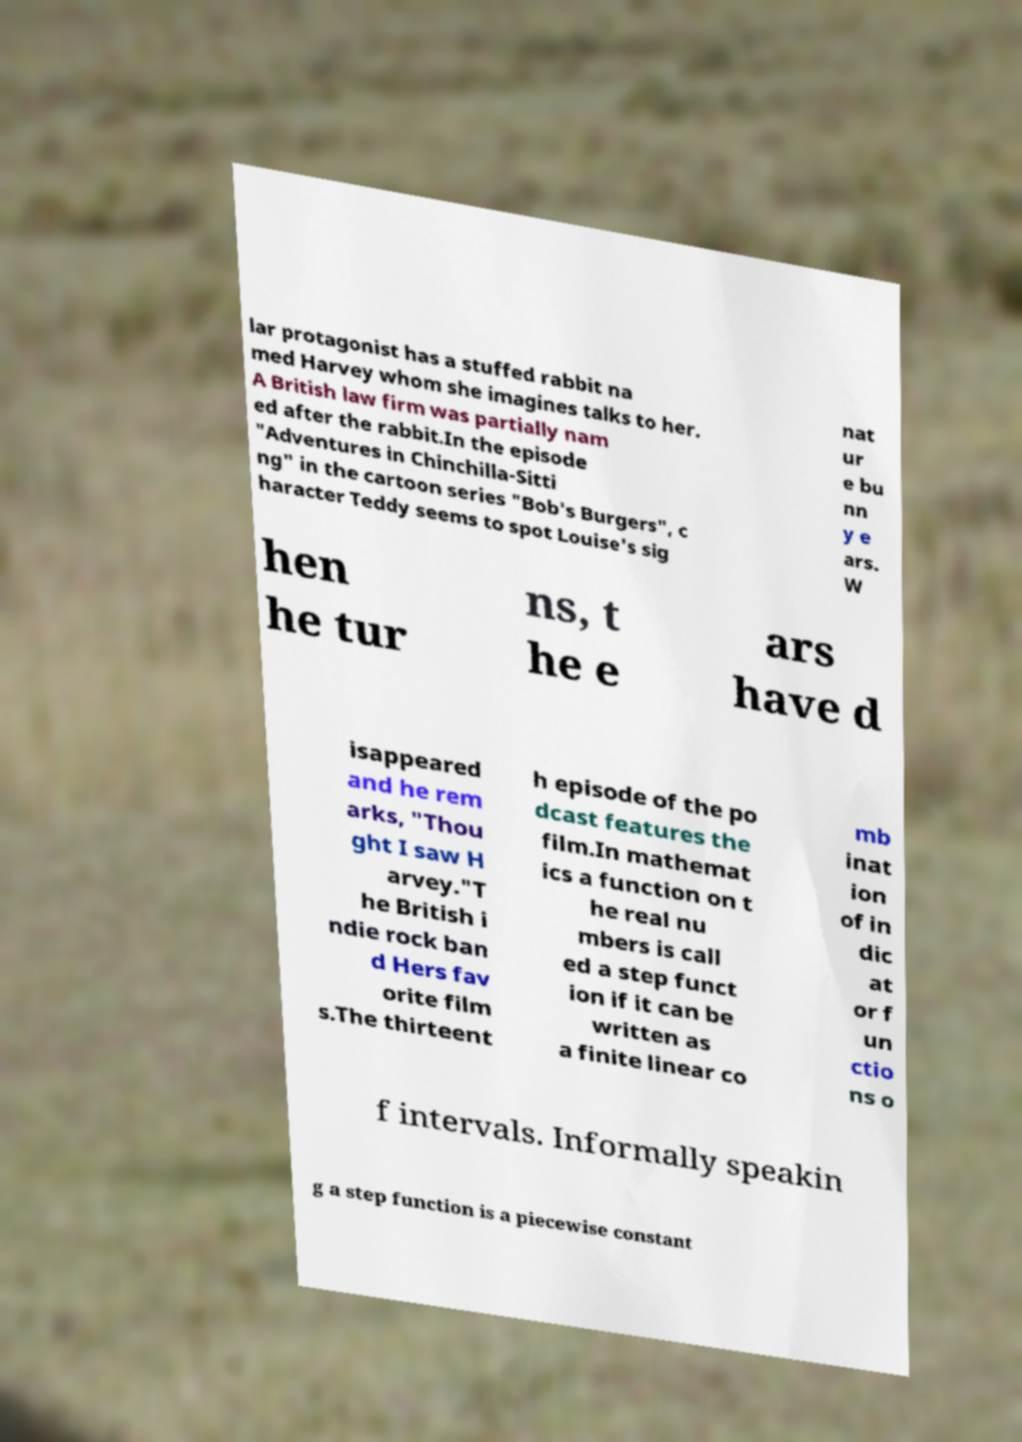Please read and relay the text visible in this image. What does it say? lar protagonist has a stuffed rabbit na med Harvey whom she imagines talks to her. A British law firm was partially nam ed after the rabbit.In the episode "Adventures in Chinchilla-Sitti ng" in the cartoon series "Bob's Burgers", c haracter Teddy seems to spot Louise's sig nat ur e bu nn y e ars. W hen he tur ns, t he e ars have d isappeared and he rem arks, "Thou ght I saw H arvey."T he British i ndie rock ban d Hers fav orite film s.The thirteent h episode of the po dcast features the film.In mathemat ics a function on t he real nu mbers is call ed a step funct ion if it can be written as a finite linear co mb inat ion of in dic at or f un ctio ns o f intervals. Informally speakin g a step function is a piecewise constant 